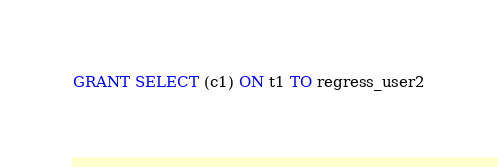Convert code to text. <code><loc_0><loc_0><loc_500><loc_500><_SQL_>GRANT SELECT (c1) ON t1 TO regress_user2
</code> 